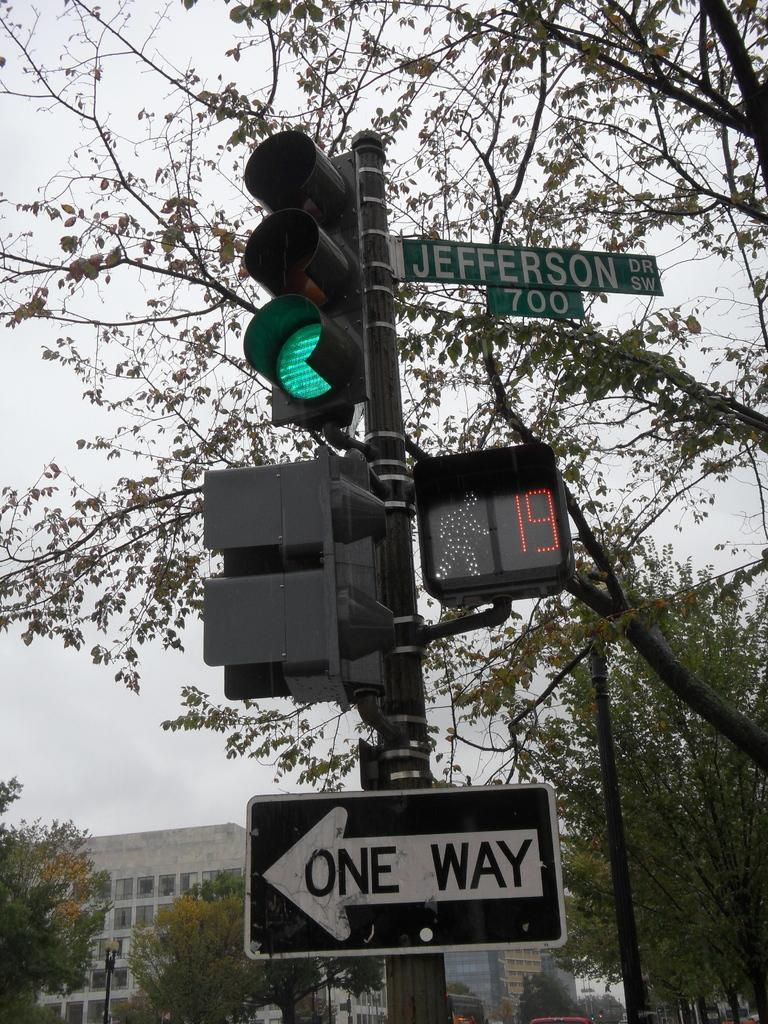<image>
Render a clear and concise summary of the photo. street signs for Jefferson Drive and One Way by traffic lights 